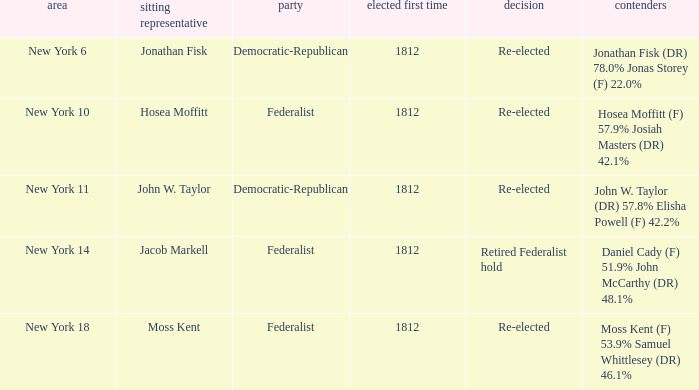Name the incumbent for new york 10 Hosea Moffitt. 